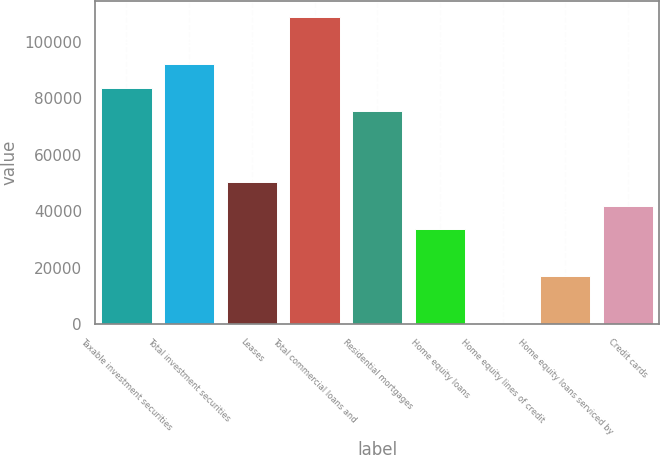Convert chart. <chart><loc_0><loc_0><loc_500><loc_500><bar_chart><fcel>Taxable investment securities<fcel>Total investment securities<fcel>Leases<fcel>Total commercial loans and<fcel>Residential mortgages<fcel>Home equity loans<fcel>Home equity lines of credit<fcel>Home equity loans serviced by<fcel>Credit cards<nl><fcel>83740<fcel>92095.9<fcel>50316.4<fcel>108808<fcel>75384.1<fcel>33604.6<fcel>181<fcel>16892.8<fcel>41960.5<nl></chart> 